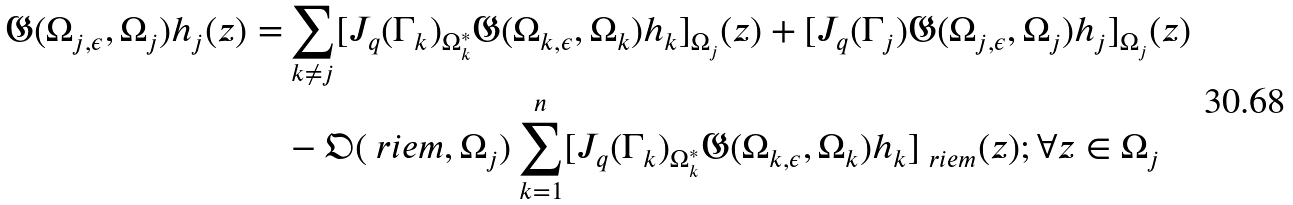Convert formula to latex. <formula><loc_0><loc_0><loc_500><loc_500>\mathfrak { G } ( \Omega _ { j , \epsilon } , \Omega _ { j } ) h _ { j } ( z ) = & \sum _ { k \neq j } [ J _ { q } ( \Gamma _ { k } ) _ { \Omega ^ { * } _ { k } } \mathfrak { G } ( \Omega _ { k , \epsilon } , \Omega _ { k } ) h _ { k } ] _ { \Omega _ { j } } ( z ) + [ J _ { q } ( \Gamma _ { j } ) \mathfrak { G } ( \Omega _ { j , \epsilon } , \Omega _ { j } ) h _ { j } ] _ { \Omega _ { j } } ( z ) \\ & - \mathfrak { O } ( \ r i e m , \Omega _ { j } ) \sum _ { k = 1 } ^ { n } [ J _ { q } ( \Gamma _ { k } ) _ { \Omega ^ { * } _ { k } } \mathfrak { G } ( \Omega _ { k , \epsilon } , \Omega _ { k } ) h _ { k } ] _ { \ r i e m } ( z ) ; \forall z \in \Omega _ { j }</formula> 